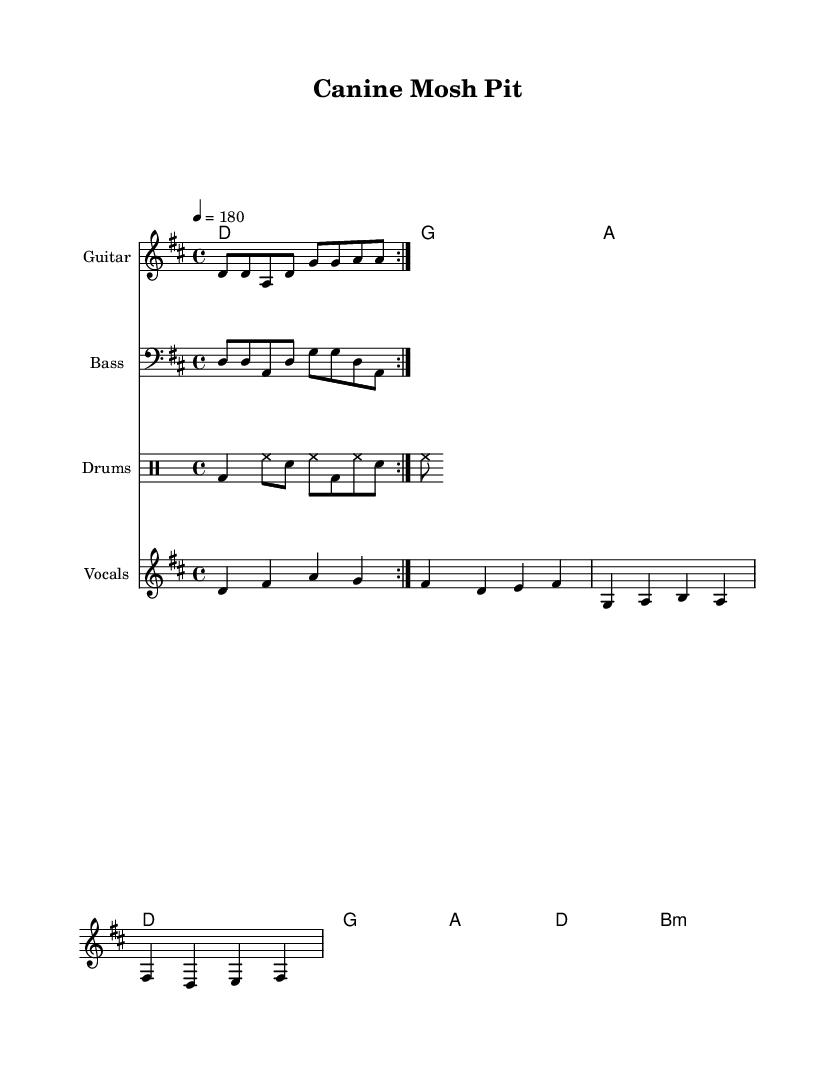What is the key signature of this music? The key signature is D major, which has two sharps: F# and C#. This can be seen at the beginning of the score.
Answer: D major What is the time signature of the piece? The time signature is 4/4, which indicates four beats per measure. This information is located at the start of the score near the key signature.
Answer: 4/4 What is the tempo marking for this music? The tempo marking is 180 beats per minute, as indicated with the notation "4 = 180". This shows how many beats occur in one minute.
Answer: 180 How many measures are there in the verse? The verse consists of four measures, which can be counted through the music notation provided for the melody and lyrics.
Answer: 4 What are the two types of instruments used in this piece? The instruments used are Guitar and Bass, as stated in the instrument names on the respective staffs, indicating the different parts being played.
Answer: Guitar and Bass What lyrical theme is celebrated in this song? The lyrics celebrate the bond between humans and dogs, highlighted by phrases like "fur-ry friends" and references to "the ca-nine mosh pit." This conveys a sense of joy and companionship.
Answer: Humans and dogs What is the name of this song? The song is titled "Canine Mosh Pit," which is mentioned in the header section of the music. This title reflects the energetic and fun theme of the piece.
Answer: Canine Mosh Pit 